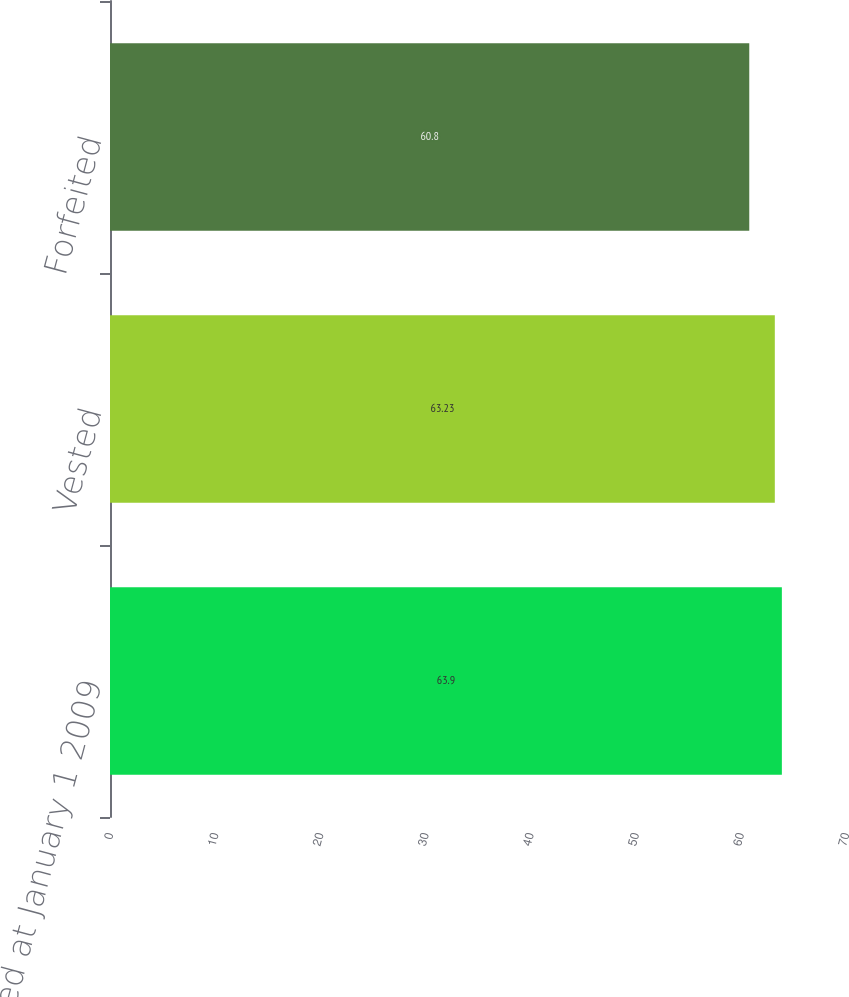<chart> <loc_0><loc_0><loc_500><loc_500><bar_chart><fcel>Nonvested at January 1 2009<fcel>Vested<fcel>Forfeited<nl><fcel>63.9<fcel>63.23<fcel>60.8<nl></chart> 